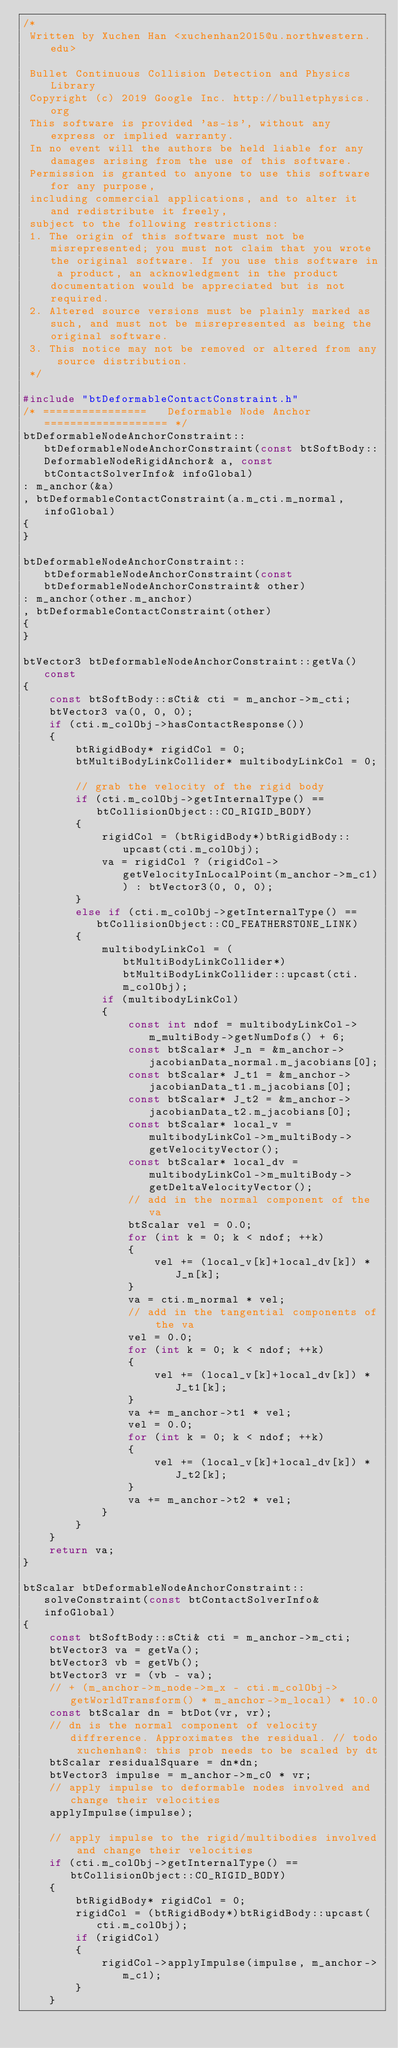Convert code to text. <code><loc_0><loc_0><loc_500><loc_500><_C++_>/*
 Written by Xuchen Han <xuchenhan2015@u.northwestern.edu>
 
 Bullet Continuous Collision Detection and Physics Library
 Copyright (c) 2019 Google Inc. http://bulletphysics.org
 This software is provided 'as-is', without any express or implied warranty.
 In no event will the authors be held liable for any damages arising from the use of this software.
 Permission is granted to anyone to use this software for any purpose,
 including commercial applications, and to alter it and redistribute it freely,
 subject to the following restrictions:
 1. The origin of this software must not be misrepresented; you must not claim that you wrote the original software. If you use this software in a product, an acknowledgment in the product documentation would be appreciated but is not required.
 2. Altered source versions must be plainly marked as such, and must not be misrepresented as being the original software.
 3. This notice may not be removed or altered from any source distribution.
 */

#include "btDeformableContactConstraint.h"
/* ================   Deformable Node Anchor   =================== */
btDeformableNodeAnchorConstraint::btDeformableNodeAnchorConstraint(const btSoftBody::DeformableNodeRigidAnchor& a, const btContactSolverInfo& infoGlobal)
: m_anchor(&a)
, btDeformableContactConstraint(a.m_cti.m_normal, infoGlobal)
{
}

btDeformableNodeAnchorConstraint::btDeformableNodeAnchorConstraint(const btDeformableNodeAnchorConstraint& other)
: m_anchor(other.m_anchor)
, btDeformableContactConstraint(other)
{
}

btVector3 btDeformableNodeAnchorConstraint::getVa() const
{
    const btSoftBody::sCti& cti = m_anchor->m_cti;
    btVector3 va(0, 0, 0);
    if (cti.m_colObj->hasContactResponse())
    {
        btRigidBody* rigidCol = 0;
        btMultiBodyLinkCollider* multibodyLinkCol = 0;
        
        // grab the velocity of the rigid body
        if (cti.m_colObj->getInternalType() == btCollisionObject::CO_RIGID_BODY)
        {
            rigidCol = (btRigidBody*)btRigidBody::upcast(cti.m_colObj);
            va = rigidCol ? (rigidCol->getVelocityInLocalPoint(m_anchor->m_c1)) : btVector3(0, 0, 0);
        }
        else if (cti.m_colObj->getInternalType() == btCollisionObject::CO_FEATHERSTONE_LINK)
        {
            multibodyLinkCol = (btMultiBodyLinkCollider*)btMultiBodyLinkCollider::upcast(cti.m_colObj);
            if (multibodyLinkCol)
            {
                const int ndof = multibodyLinkCol->m_multiBody->getNumDofs() + 6;
                const btScalar* J_n = &m_anchor->jacobianData_normal.m_jacobians[0];
                const btScalar* J_t1 = &m_anchor->jacobianData_t1.m_jacobians[0];
                const btScalar* J_t2 = &m_anchor->jacobianData_t2.m_jacobians[0];
                const btScalar* local_v = multibodyLinkCol->m_multiBody->getVelocityVector();
                const btScalar* local_dv = multibodyLinkCol->m_multiBody->getDeltaVelocityVector();
                // add in the normal component of the va
                btScalar vel = 0.0;
                for (int k = 0; k < ndof; ++k)
                {
                    vel += (local_v[k]+local_dv[k]) * J_n[k];
                }
                va = cti.m_normal * vel;
                // add in the tangential components of the va
                vel = 0.0;
                for (int k = 0; k < ndof; ++k)
                {
                    vel += (local_v[k]+local_dv[k]) * J_t1[k];
                }
                va += m_anchor->t1 * vel;
                vel = 0.0;
                for (int k = 0; k < ndof; ++k)
                {
                    vel += (local_v[k]+local_dv[k]) * J_t2[k];
                }
                va += m_anchor->t2 * vel;
            }
        }
    }
    return va;
}

btScalar btDeformableNodeAnchorConstraint::solveConstraint(const btContactSolverInfo& infoGlobal)
{
    const btSoftBody::sCti& cti = m_anchor->m_cti;
    btVector3 va = getVa();
    btVector3 vb = getVb();
    btVector3 vr = (vb - va);
    // + (m_anchor->m_node->m_x - cti.m_colObj->getWorldTransform() * m_anchor->m_local) * 10.0
    const btScalar dn = btDot(vr, vr);
    // dn is the normal component of velocity diffrerence. Approximates the residual. // todo xuchenhan@: this prob needs to be scaled by dt
    btScalar residualSquare = dn*dn;
    btVector3 impulse = m_anchor->m_c0 * vr;
    // apply impulse to deformable nodes involved and change their velocities
    applyImpulse(impulse);
    
    // apply impulse to the rigid/multibodies involved and change their velocities
    if (cti.m_colObj->getInternalType() == btCollisionObject::CO_RIGID_BODY)
    {
        btRigidBody* rigidCol = 0;
        rigidCol = (btRigidBody*)btRigidBody::upcast(cti.m_colObj);
        if (rigidCol)
        {
            rigidCol->applyImpulse(impulse, m_anchor->m_c1);
        }
    }</code> 